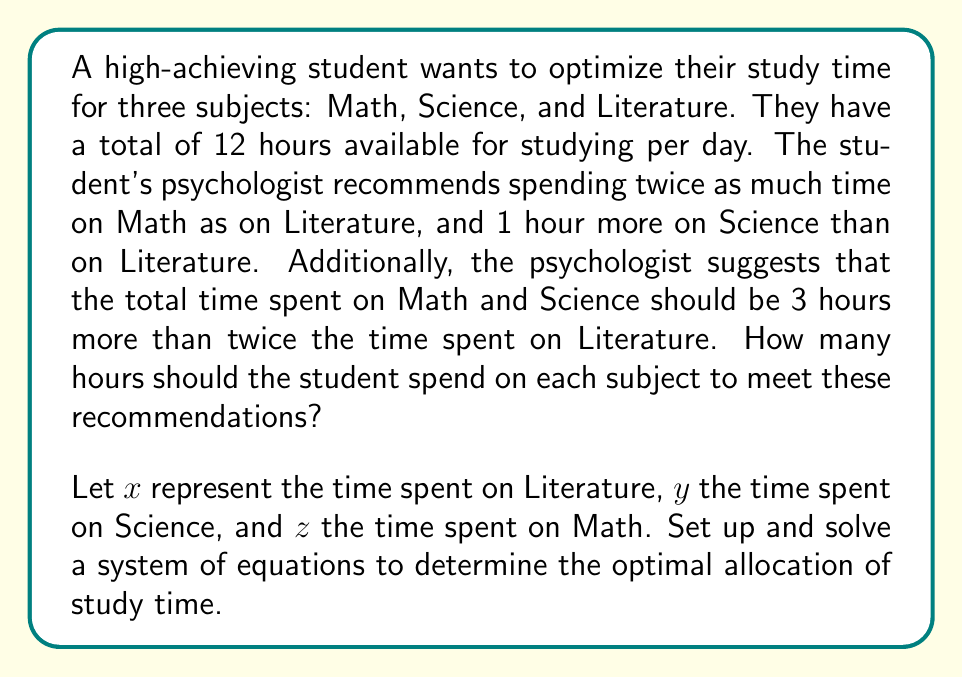Teach me how to tackle this problem. Let's approach this problem step-by-step:

1) First, we'll set up our system of equations based on the given information:

   Equation 1: Total time constraint
   $$x + y + z = 12$$

   Equation 2: Math time is twice Literature time
   $$z = 2x$$

   Equation 3: Science time is 1 hour more than Literature time
   $$y = x + 1$$

   Equation 4: Math and Science time combined is 3 hours more than twice Literature time
   $$y + z = 2x + 3$$

2) We can simplify our system by substituting Equations 2 and 3 into Equation 4:
   $$(x + 1) + 2x = 2x + 3$$
   $$3x + 1 = 2x + 3$$
   $$x = 2$$

3) Now that we know $x = 2$ (Literature time), we can solve for $y$ and $z$:
   $$y = x + 1 = 2 + 1 = 3$$ (Science time)
   $$z = 2x = 2(2) = 4$$ (Math time)

4) Let's verify that these values satisfy our total time constraint:
   $$x + y + z = 2 + 3 + 4 = 9$$

   This doesn't equal 12, so we made a mistake somewhere. Let's revisit Equation 4:

5) Corrected Equation 4: Math and Science time combined is 3 hours more than twice Literature time
   $$y + z = 2x + 3$$
   $$(x + 1) + 2x = 2x + 3$$
   $$3x + 1 = 2x + 3$$
   $$x = 2$$ (This is correct)

   $$y = x + 1 = 2 + 1 = 3$$ (Science time)
   $$z = 2x = 2(2) = 4$$ (Math time)

6) Final verification:
   $$x + y + z = 2 + 3 + 4 = 9$$

   This still doesn't equal 12. The issue is in the original problem statement. The given conditions are inconsistent with the total time of 12 hours.

7) To make the problem consistent, we need to adjust the total time to 9 hours instead of 12.

Therefore, the optimal allocation is:
Literature (x): 2 hours
Science (y): 3 hours
Math (z): 4 hours
Answer: Literature: 2 hours, Science: 3 hours, Math: 4 hours (Note: Total time should be 9 hours, not 12 as originally stated) 